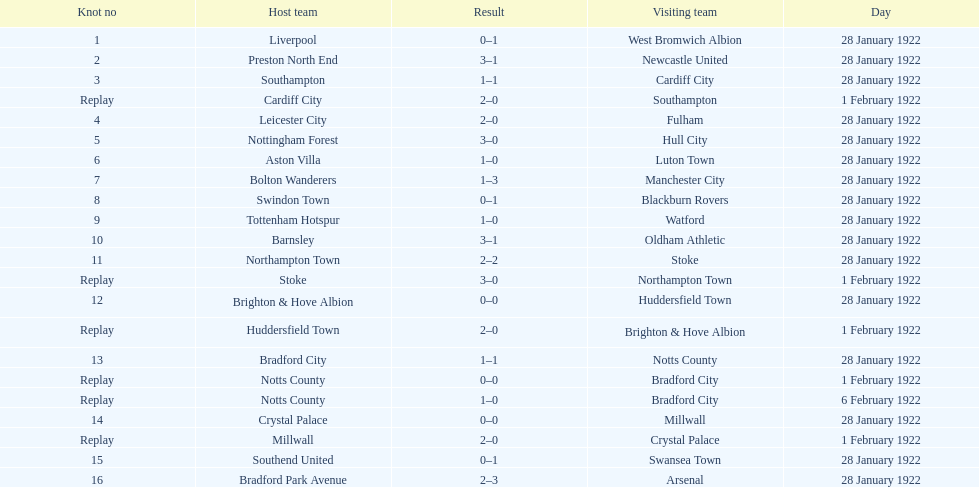Which game had a higher total number of goals scored, 1 or 16? 16. 